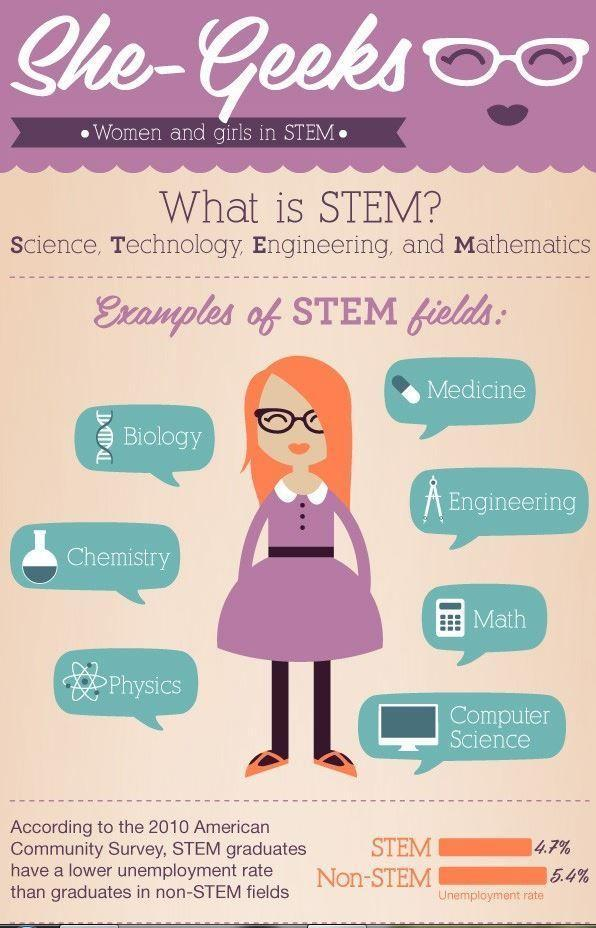What is the unemployment rate in stem graduates according to the 2010 American community survey?
Answer the question with a short phrase. 4.7% 